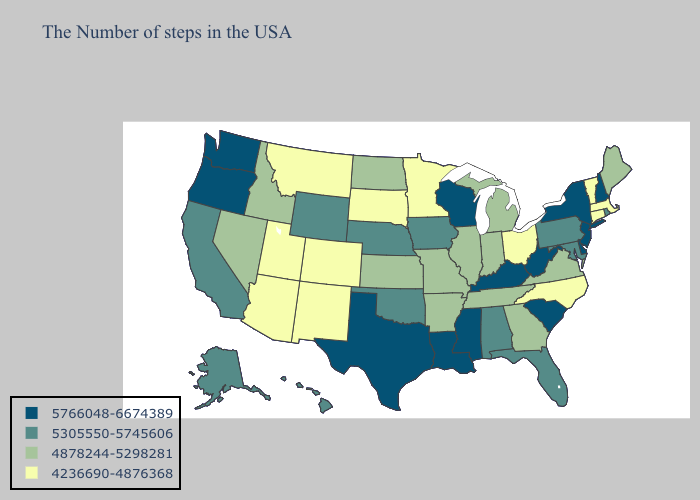What is the value of Louisiana?
Quick response, please. 5766048-6674389. Does Wyoming have the lowest value in the West?
Short answer required. No. Does Wyoming have the lowest value in the West?
Be succinct. No. Does Massachusetts have the lowest value in the USA?
Keep it brief. Yes. Name the states that have a value in the range 4878244-5298281?
Answer briefly. Maine, Virginia, Georgia, Michigan, Indiana, Tennessee, Illinois, Missouri, Arkansas, Kansas, North Dakota, Idaho, Nevada. What is the lowest value in the USA?
Concise answer only. 4236690-4876368. Name the states that have a value in the range 4878244-5298281?
Keep it brief. Maine, Virginia, Georgia, Michigan, Indiana, Tennessee, Illinois, Missouri, Arkansas, Kansas, North Dakota, Idaho, Nevada. Which states have the highest value in the USA?
Be succinct. New Hampshire, New York, New Jersey, Delaware, South Carolina, West Virginia, Kentucky, Wisconsin, Mississippi, Louisiana, Texas, Washington, Oregon. Does the map have missing data?
Quick response, please. No. What is the value of Colorado?
Keep it brief. 4236690-4876368. Among the states that border Illinois , does Wisconsin have the lowest value?
Quick response, please. No. Name the states that have a value in the range 5305550-5745606?
Quick response, please. Rhode Island, Maryland, Pennsylvania, Florida, Alabama, Iowa, Nebraska, Oklahoma, Wyoming, California, Alaska, Hawaii. How many symbols are there in the legend?
Short answer required. 4. Which states have the lowest value in the USA?
Give a very brief answer. Massachusetts, Vermont, Connecticut, North Carolina, Ohio, Minnesota, South Dakota, Colorado, New Mexico, Utah, Montana, Arizona. Name the states that have a value in the range 4236690-4876368?
Short answer required. Massachusetts, Vermont, Connecticut, North Carolina, Ohio, Minnesota, South Dakota, Colorado, New Mexico, Utah, Montana, Arizona. 